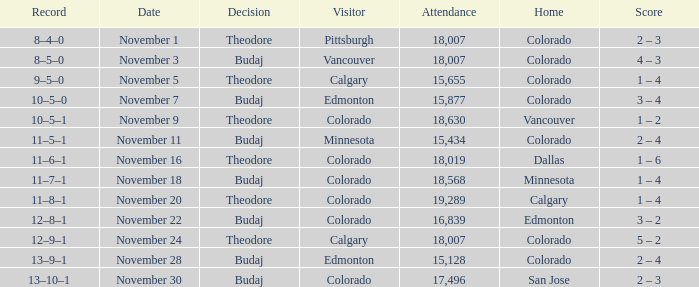Who was the Home Team while Calgary was visiting while having an Attendance above 15,655? Colorado. 